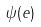Convert formula to latex. <formula><loc_0><loc_0><loc_500><loc_500>\psi ( e )</formula> 